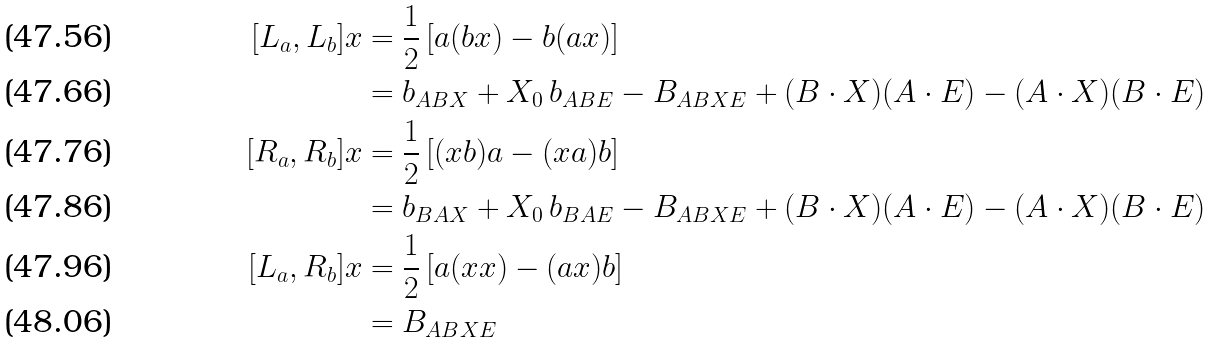Convert formula to latex. <formula><loc_0><loc_0><loc_500><loc_500>[ L _ { a } , L _ { b } ] x & = \frac { 1 } { 2 } \left [ a ( b x ) - b ( a x ) \right ] \\ & = b _ { A B X } + X _ { 0 } \, b _ { A B E } - B _ { A B X E } + ( B \cdot X ) ( A \cdot E ) - ( A \cdot X ) ( B \cdot E ) \\ [ R _ { a } , R _ { b } ] x & = \frac { 1 } { 2 } \left [ ( x b ) a - ( x a ) b \right ] \\ & = b _ { B A X } + X _ { 0 } \, b _ { B A E } - B _ { A B X E } + ( B \cdot X ) ( A \cdot E ) - ( A \cdot X ) ( B \cdot E ) \\ [ L _ { a } , R _ { b } ] x & = \frac { 1 } { 2 } \left [ a ( x x ) - ( a x ) b \right ] \\ & = B _ { A B X E }</formula> 